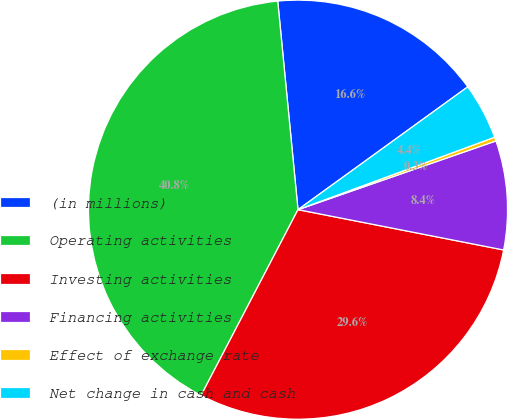Convert chart. <chart><loc_0><loc_0><loc_500><loc_500><pie_chart><fcel>(in millions)<fcel>Operating activities<fcel>Investing activities<fcel>Financing activities<fcel>Effect of exchange rate<fcel>Net change in cash and cash<nl><fcel>16.57%<fcel>40.8%<fcel>29.57%<fcel>8.4%<fcel>0.3%<fcel>4.35%<nl></chart> 